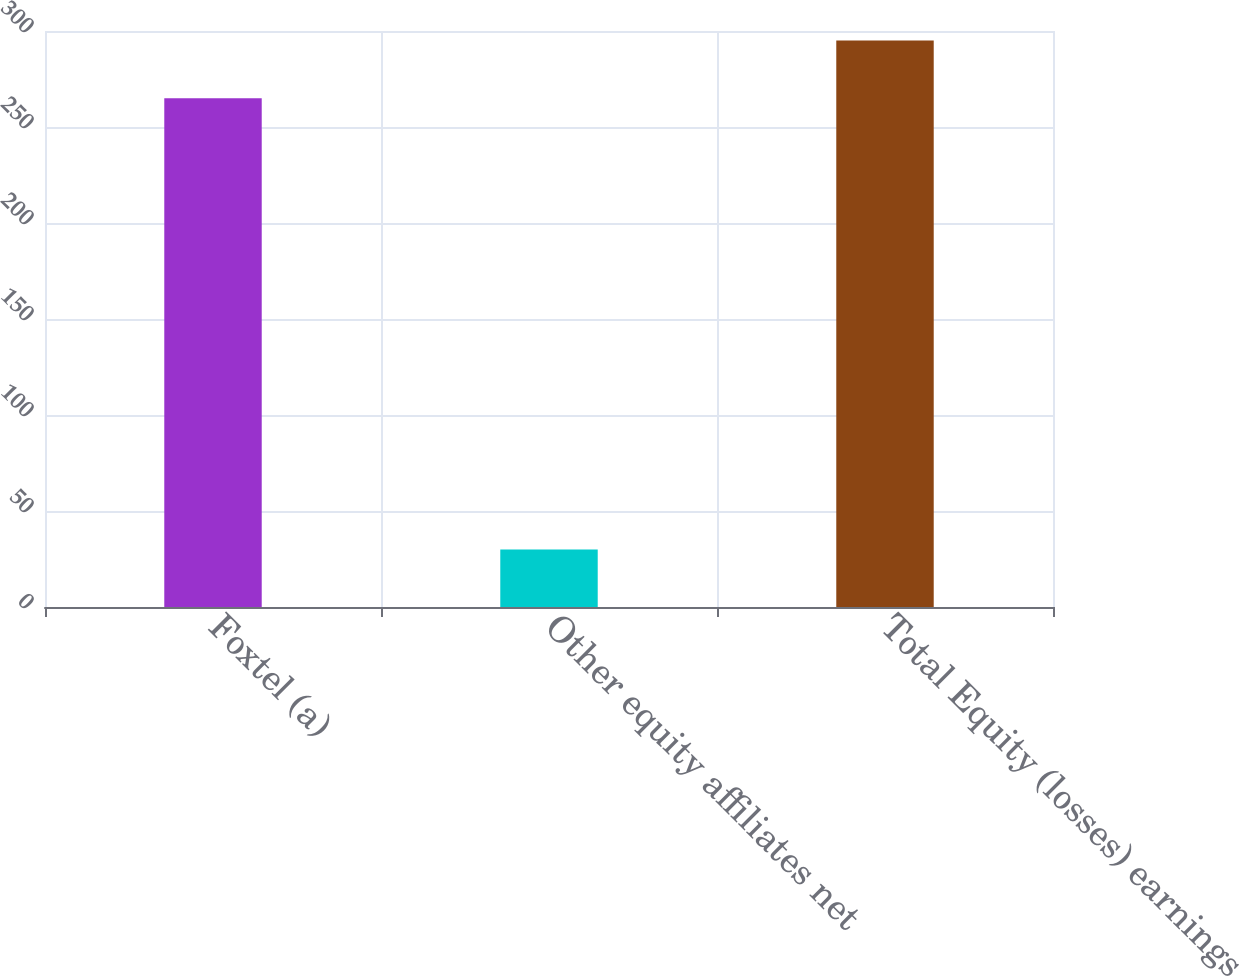Convert chart to OTSL. <chart><loc_0><loc_0><loc_500><loc_500><bar_chart><fcel>Foxtel (a)<fcel>Other equity affiliates net<fcel>Total Equity (losses) earnings<nl><fcel>265<fcel>30<fcel>295<nl></chart> 